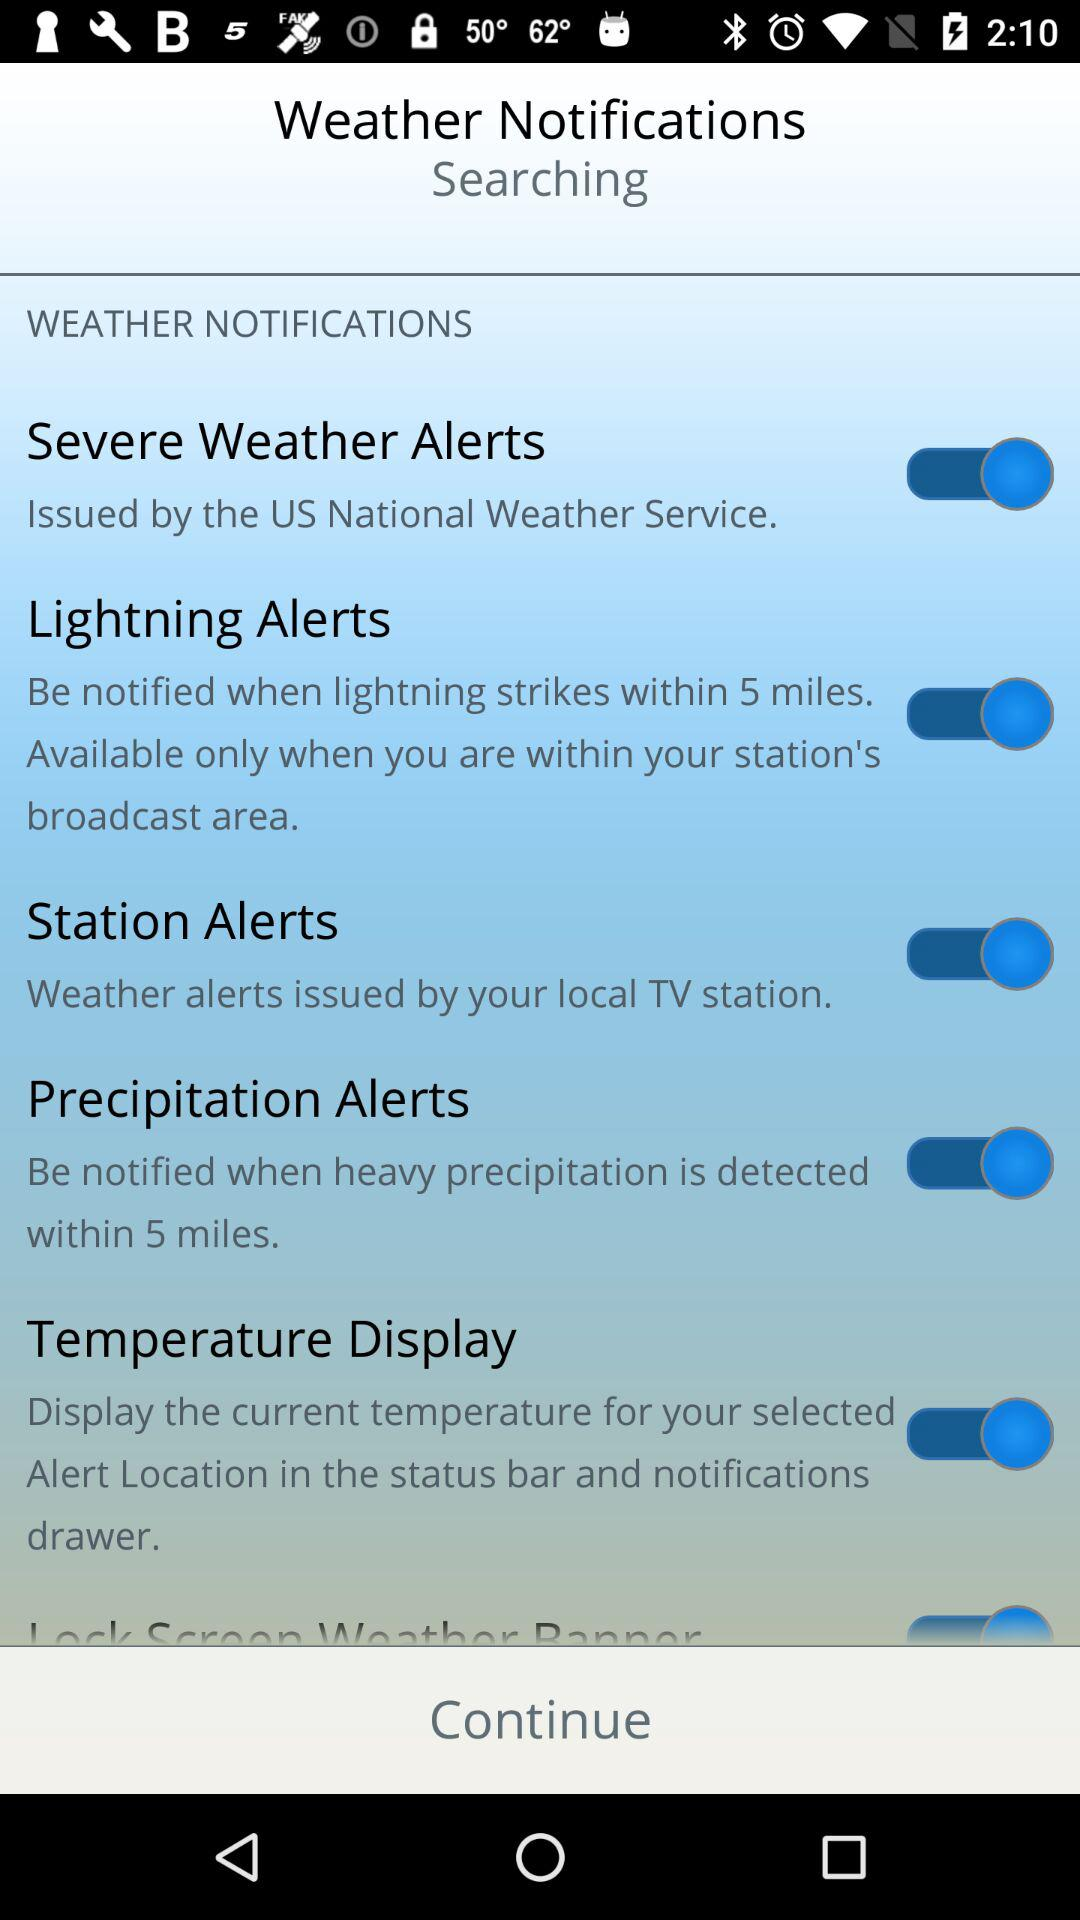When does "Lightning Alerts" activate? Lightning alarts activate "when lightning strikes within 5 miles". 